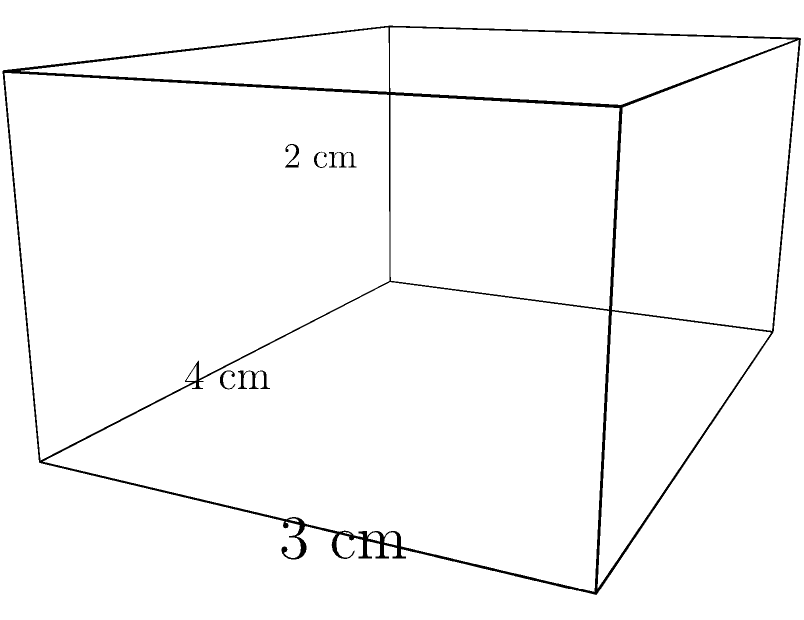A medication storage box for MS treatments is shaped like a rectangular prism with dimensions 4 cm × 3 cm × 2 cm. What is the total surface area of this storage box? To find the surface area of a rectangular prism, we need to calculate the area of each face and sum them up. Let's break it down step-by-step:

1) A rectangular prism has 6 faces: 2 identical faces for each dimension.

2) Calculate the area of each pair of faces:
   - Front and back faces: $4 \text{ cm} \times 2 \text{ cm} = 8 \text{ cm}^2$ each
   - Top and bottom faces: $4 \text{ cm} \times 3 \text{ cm} = 12 \text{ cm}^2$ each
   - Left and right faces: $3 \text{ cm} \times 2 \text{ cm} = 6 \text{ cm}^2$ each

3) Sum up the areas:
   $$(2 \times 8 \text{ cm}^2) + (2 \times 12 \text{ cm}^2) + (2 \times 6 \text{ cm}^2)$$
   $$= 16 \text{ cm}^2 + 24 \text{ cm}^2 + 12 \text{ cm}^2$$
   $$= 52 \text{ cm}^2$$

Therefore, the total surface area of the medication storage box is 52 cm².
Answer: 52 cm² 